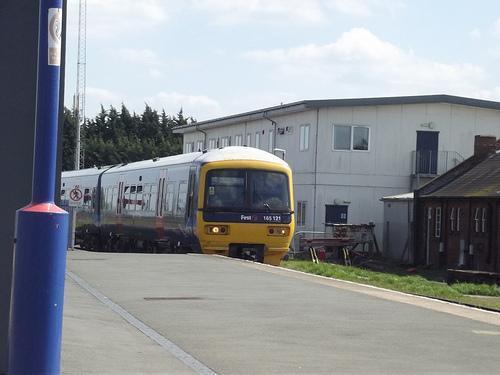How many cars of the train are visible?
Give a very brief answer. 2. 